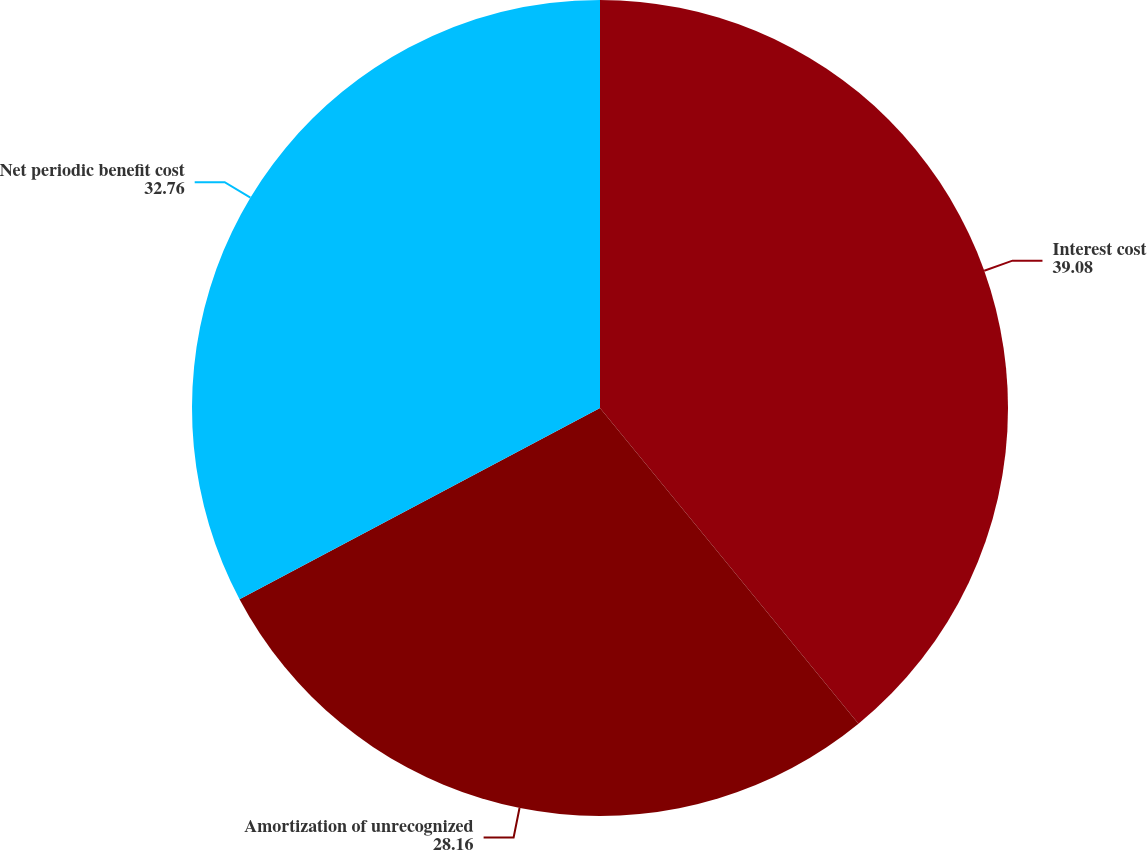<chart> <loc_0><loc_0><loc_500><loc_500><pie_chart><fcel>Interest cost<fcel>Amortization of unrecognized<fcel>Net periodic benefit cost<nl><fcel>39.08%<fcel>28.16%<fcel>32.76%<nl></chart> 